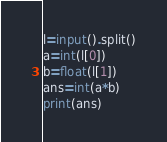<code> <loc_0><loc_0><loc_500><loc_500><_Python_>l=input().split()
a=int(l[0])
b=float(l[1])
ans=int(a*b)
print(ans)
</code> 